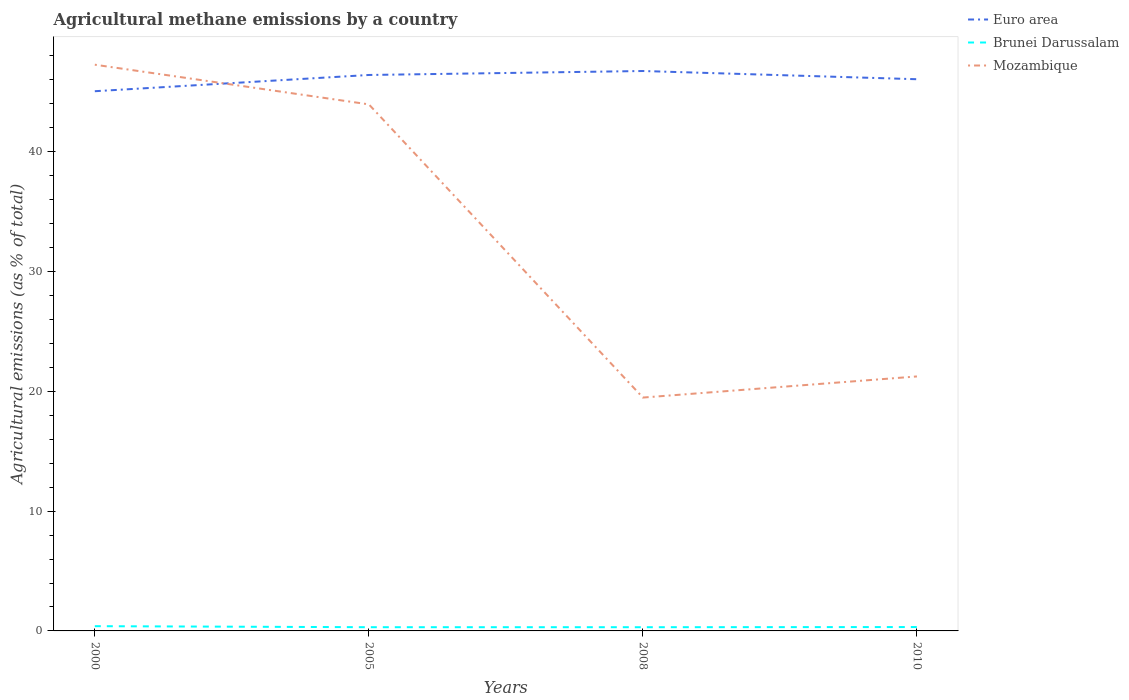How many different coloured lines are there?
Your response must be concise. 3. Across all years, what is the maximum amount of agricultural methane emitted in Brunei Darussalam?
Make the answer very short. 0.31. In which year was the amount of agricultural methane emitted in Mozambique maximum?
Keep it short and to the point. 2008. What is the total amount of agricultural methane emitted in Brunei Darussalam in the graph?
Offer a terse response. 0. What is the difference between the highest and the second highest amount of agricultural methane emitted in Euro area?
Provide a succinct answer. 1.69. How many lines are there?
Ensure brevity in your answer.  3. How many years are there in the graph?
Offer a terse response. 4. What is the difference between two consecutive major ticks on the Y-axis?
Give a very brief answer. 10. Does the graph contain grids?
Make the answer very short. No. What is the title of the graph?
Your answer should be compact. Agricultural methane emissions by a country. Does "Moldova" appear as one of the legend labels in the graph?
Your answer should be compact. No. What is the label or title of the Y-axis?
Ensure brevity in your answer.  Agricultural emissions (as % of total). What is the Agricultural emissions (as % of total) of Euro area in 2000?
Make the answer very short. 45.06. What is the Agricultural emissions (as % of total) in Brunei Darussalam in 2000?
Offer a terse response. 0.4. What is the Agricultural emissions (as % of total) of Mozambique in 2000?
Your answer should be very brief. 47.27. What is the Agricultural emissions (as % of total) of Euro area in 2005?
Your answer should be compact. 46.41. What is the Agricultural emissions (as % of total) of Brunei Darussalam in 2005?
Offer a very short reply. 0.31. What is the Agricultural emissions (as % of total) of Mozambique in 2005?
Ensure brevity in your answer.  43.96. What is the Agricultural emissions (as % of total) in Euro area in 2008?
Your response must be concise. 46.74. What is the Agricultural emissions (as % of total) of Brunei Darussalam in 2008?
Your answer should be compact. 0.31. What is the Agricultural emissions (as % of total) of Mozambique in 2008?
Your response must be concise. 19.48. What is the Agricultural emissions (as % of total) in Euro area in 2010?
Offer a terse response. 46.06. What is the Agricultural emissions (as % of total) in Brunei Darussalam in 2010?
Keep it short and to the point. 0.32. What is the Agricultural emissions (as % of total) of Mozambique in 2010?
Give a very brief answer. 21.24. Across all years, what is the maximum Agricultural emissions (as % of total) in Euro area?
Offer a terse response. 46.74. Across all years, what is the maximum Agricultural emissions (as % of total) in Brunei Darussalam?
Your response must be concise. 0.4. Across all years, what is the maximum Agricultural emissions (as % of total) of Mozambique?
Keep it short and to the point. 47.27. Across all years, what is the minimum Agricultural emissions (as % of total) in Euro area?
Offer a terse response. 45.06. Across all years, what is the minimum Agricultural emissions (as % of total) of Brunei Darussalam?
Give a very brief answer. 0.31. Across all years, what is the minimum Agricultural emissions (as % of total) in Mozambique?
Make the answer very short. 19.48. What is the total Agricultural emissions (as % of total) in Euro area in the graph?
Offer a terse response. 184.26. What is the total Agricultural emissions (as % of total) in Brunei Darussalam in the graph?
Provide a short and direct response. 1.34. What is the total Agricultural emissions (as % of total) of Mozambique in the graph?
Offer a very short reply. 131.95. What is the difference between the Agricultural emissions (as % of total) in Euro area in 2000 and that in 2005?
Offer a terse response. -1.36. What is the difference between the Agricultural emissions (as % of total) of Brunei Darussalam in 2000 and that in 2005?
Offer a very short reply. 0.09. What is the difference between the Agricultural emissions (as % of total) in Mozambique in 2000 and that in 2005?
Offer a terse response. 3.31. What is the difference between the Agricultural emissions (as % of total) in Euro area in 2000 and that in 2008?
Make the answer very short. -1.69. What is the difference between the Agricultural emissions (as % of total) in Brunei Darussalam in 2000 and that in 2008?
Provide a short and direct response. 0.09. What is the difference between the Agricultural emissions (as % of total) in Mozambique in 2000 and that in 2008?
Provide a succinct answer. 27.79. What is the difference between the Agricultural emissions (as % of total) of Euro area in 2000 and that in 2010?
Give a very brief answer. -1. What is the difference between the Agricultural emissions (as % of total) in Brunei Darussalam in 2000 and that in 2010?
Your answer should be very brief. 0.07. What is the difference between the Agricultural emissions (as % of total) of Mozambique in 2000 and that in 2010?
Your answer should be very brief. 26.02. What is the difference between the Agricultural emissions (as % of total) in Euro area in 2005 and that in 2008?
Ensure brevity in your answer.  -0.33. What is the difference between the Agricultural emissions (as % of total) in Brunei Darussalam in 2005 and that in 2008?
Your response must be concise. 0. What is the difference between the Agricultural emissions (as % of total) of Mozambique in 2005 and that in 2008?
Provide a succinct answer. 24.48. What is the difference between the Agricultural emissions (as % of total) of Euro area in 2005 and that in 2010?
Your response must be concise. 0.36. What is the difference between the Agricultural emissions (as % of total) of Brunei Darussalam in 2005 and that in 2010?
Offer a terse response. -0.01. What is the difference between the Agricultural emissions (as % of total) of Mozambique in 2005 and that in 2010?
Give a very brief answer. 22.71. What is the difference between the Agricultural emissions (as % of total) in Euro area in 2008 and that in 2010?
Offer a terse response. 0.69. What is the difference between the Agricultural emissions (as % of total) of Brunei Darussalam in 2008 and that in 2010?
Ensure brevity in your answer.  -0.01. What is the difference between the Agricultural emissions (as % of total) of Mozambique in 2008 and that in 2010?
Offer a very short reply. -1.76. What is the difference between the Agricultural emissions (as % of total) in Euro area in 2000 and the Agricultural emissions (as % of total) in Brunei Darussalam in 2005?
Keep it short and to the point. 44.74. What is the difference between the Agricultural emissions (as % of total) of Euro area in 2000 and the Agricultural emissions (as % of total) of Mozambique in 2005?
Give a very brief answer. 1.1. What is the difference between the Agricultural emissions (as % of total) of Brunei Darussalam in 2000 and the Agricultural emissions (as % of total) of Mozambique in 2005?
Provide a short and direct response. -43.56. What is the difference between the Agricultural emissions (as % of total) of Euro area in 2000 and the Agricultural emissions (as % of total) of Brunei Darussalam in 2008?
Keep it short and to the point. 44.75. What is the difference between the Agricultural emissions (as % of total) in Euro area in 2000 and the Agricultural emissions (as % of total) in Mozambique in 2008?
Make the answer very short. 25.57. What is the difference between the Agricultural emissions (as % of total) in Brunei Darussalam in 2000 and the Agricultural emissions (as % of total) in Mozambique in 2008?
Your answer should be very brief. -19.08. What is the difference between the Agricultural emissions (as % of total) in Euro area in 2000 and the Agricultural emissions (as % of total) in Brunei Darussalam in 2010?
Make the answer very short. 44.73. What is the difference between the Agricultural emissions (as % of total) of Euro area in 2000 and the Agricultural emissions (as % of total) of Mozambique in 2010?
Make the answer very short. 23.81. What is the difference between the Agricultural emissions (as % of total) in Brunei Darussalam in 2000 and the Agricultural emissions (as % of total) in Mozambique in 2010?
Give a very brief answer. -20.85. What is the difference between the Agricultural emissions (as % of total) of Euro area in 2005 and the Agricultural emissions (as % of total) of Brunei Darussalam in 2008?
Ensure brevity in your answer.  46.1. What is the difference between the Agricultural emissions (as % of total) in Euro area in 2005 and the Agricultural emissions (as % of total) in Mozambique in 2008?
Offer a very short reply. 26.93. What is the difference between the Agricultural emissions (as % of total) in Brunei Darussalam in 2005 and the Agricultural emissions (as % of total) in Mozambique in 2008?
Make the answer very short. -19.17. What is the difference between the Agricultural emissions (as % of total) in Euro area in 2005 and the Agricultural emissions (as % of total) in Brunei Darussalam in 2010?
Ensure brevity in your answer.  46.09. What is the difference between the Agricultural emissions (as % of total) in Euro area in 2005 and the Agricultural emissions (as % of total) in Mozambique in 2010?
Keep it short and to the point. 25.17. What is the difference between the Agricultural emissions (as % of total) of Brunei Darussalam in 2005 and the Agricultural emissions (as % of total) of Mozambique in 2010?
Offer a terse response. -20.93. What is the difference between the Agricultural emissions (as % of total) in Euro area in 2008 and the Agricultural emissions (as % of total) in Brunei Darussalam in 2010?
Keep it short and to the point. 46.42. What is the difference between the Agricultural emissions (as % of total) in Euro area in 2008 and the Agricultural emissions (as % of total) in Mozambique in 2010?
Ensure brevity in your answer.  25.5. What is the difference between the Agricultural emissions (as % of total) in Brunei Darussalam in 2008 and the Agricultural emissions (as % of total) in Mozambique in 2010?
Your response must be concise. -20.93. What is the average Agricultural emissions (as % of total) of Euro area per year?
Ensure brevity in your answer.  46.07. What is the average Agricultural emissions (as % of total) of Brunei Darussalam per year?
Offer a terse response. 0.34. What is the average Agricultural emissions (as % of total) of Mozambique per year?
Provide a short and direct response. 32.99. In the year 2000, what is the difference between the Agricultural emissions (as % of total) of Euro area and Agricultural emissions (as % of total) of Brunei Darussalam?
Provide a short and direct response. 44.66. In the year 2000, what is the difference between the Agricultural emissions (as % of total) in Euro area and Agricultural emissions (as % of total) in Mozambique?
Make the answer very short. -2.21. In the year 2000, what is the difference between the Agricultural emissions (as % of total) of Brunei Darussalam and Agricultural emissions (as % of total) of Mozambique?
Keep it short and to the point. -46.87. In the year 2005, what is the difference between the Agricultural emissions (as % of total) of Euro area and Agricultural emissions (as % of total) of Brunei Darussalam?
Your answer should be compact. 46.1. In the year 2005, what is the difference between the Agricultural emissions (as % of total) of Euro area and Agricultural emissions (as % of total) of Mozambique?
Give a very brief answer. 2.45. In the year 2005, what is the difference between the Agricultural emissions (as % of total) in Brunei Darussalam and Agricultural emissions (as % of total) in Mozambique?
Ensure brevity in your answer.  -43.65. In the year 2008, what is the difference between the Agricultural emissions (as % of total) in Euro area and Agricultural emissions (as % of total) in Brunei Darussalam?
Your answer should be very brief. 46.43. In the year 2008, what is the difference between the Agricultural emissions (as % of total) of Euro area and Agricultural emissions (as % of total) of Mozambique?
Give a very brief answer. 27.26. In the year 2008, what is the difference between the Agricultural emissions (as % of total) in Brunei Darussalam and Agricultural emissions (as % of total) in Mozambique?
Keep it short and to the point. -19.17. In the year 2010, what is the difference between the Agricultural emissions (as % of total) in Euro area and Agricultural emissions (as % of total) in Brunei Darussalam?
Your answer should be very brief. 45.73. In the year 2010, what is the difference between the Agricultural emissions (as % of total) in Euro area and Agricultural emissions (as % of total) in Mozambique?
Make the answer very short. 24.81. In the year 2010, what is the difference between the Agricultural emissions (as % of total) in Brunei Darussalam and Agricultural emissions (as % of total) in Mozambique?
Offer a terse response. -20.92. What is the ratio of the Agricultural emissions (as % of total) of Euro area in 2000 to that in 2005?
Offer a very short reply. 0.97. What is the ratio of the Agricultural emissions (as % of total) in Brunei Darussalam in 2000 to that in 2005?
Offer a terse response. 1.28. What is the ratio of the Agricultural emissions (as % of total) of Mozambique in 2000 to that in 2005?
Your response must be concise. 1.08. What is the ratio of the Agricultural emissions (as % of total) in Euro area in 2000 to that in 2008?
Ensure brevity in your answer.  0.96. What is the ratio of the Agricultural emissions (as % of total) in Brunei Darussalam in 2000 to that in 2008?
Offer a very short reply. 1.28. What is the ratio of the Agricultural emissions (as % of total) in Mozambique in 2000 to that in 2008?
Make the answer very short. 2.43. What is the ratio of the Agricultural emissions (as % of total) of Euro area in 2000 to that in 2010?
Your answer should be very brief. 0.98. What is the ratio of the Agricultural emissions (as % of total) of Brunei Darussalam in 2000 to that in 2010?
Make the answer very short. 1.23. What is the ratio of the Agricultural emissions (as % of total) in Mozambique in 2000 to that in 2010?
Ensure brevity in your answer.  2.23. What is the ratio of the Agricultural emissions (as % of total) of Euro area in 2005 to that in 2008?
Keep it short and to the point. 0.99. What is the ratio of the Agricultural emissions (as % of total) in Brunei Darussalam in 2005 to that in 2008?
Your response must be concise. 1. What is the ratio of the Agricultural emissions (as % of total) of Mozambique in 2005 to that in 2008?
Provide a succinct answer. 2.26. What is the ratio of the Agricultural emissions (as % of total) of Euro area in 2005 to that in 2010?
Your response must be concise. 1.01. What is the ratio of the Agricultural emissions (as % of total) in Brunei Darussalam in 2005 to that in 2010?
Ensure brevity in your answer.  0.96. What is the ratio of the Agricultural emissions (as % of total) in Mozambique in 2005 to that in 2010?
Make the answer very short. 2.07. What is the ratio of the Agricultural emissions (as % of total) in Euro area in 2008 to that in 2010?
Provide a short and direct response. 1.01. What is the ratio of the Agricultural emissions (as % of total) in Brunei Darussalam in 2008 to that in 2010?
Your response must be concise. 0.96. What is the ratio of the Agricultural emissions (as % of total) of Mozambique in 2008 to that in 2010?
Offer a very short reply. 0.92. What is the difference between the highest and the second highest Agricultural emissions (as % of total) in Euro area?
Your answer should be very brief. 0.33. What is the difference between the highest and the second highest Agricultural emissions (as % of total) in Brunei Darussalam?
Provide a short and direct response. 0.07. What is the difference between the highest and the second highest Agricultural emissions (as % of total) in Mozambique?
Keep it short and to the point. 3.31. What is the difference between the highest and the lowest Agricultural emissions (as % of total) in Euro area?
Make the answer very short. 1.69. What is the difference between the highest and the lowest Agricultural emissions (as % of total) of Brunei Darussalam?
Provide a succinct answer. 0.09. What is the difference between the highest and the lowest Agricultural emissions (as % of total) in Mozambique?
Your answer should be very brief. 27.79. 